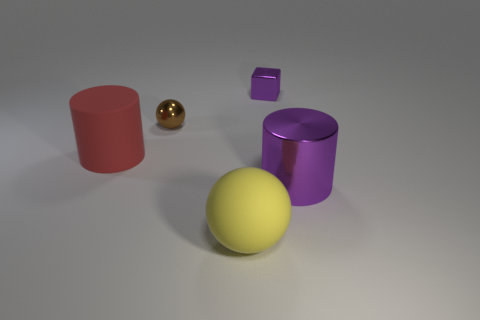Add 5 tiny red matte things. How many objects exist? 10 Subtract all purple cylinders. How many cylinders are left? 1 Subtract all cubes. How many objects are left? 4 Subtract all brown cylinders. How many gray blocks are left? 0 Subtract all yellow rubber spheres. Subtract all purple objects. How many objects are left? 2 Add 2 purple cylinders. How many purple cylinders are left? 3 Add 2 big gray objects. How many big gray objects exist? 2 Subtract 0 green balls. How many objects are left? 5 Subtract 1 spheres. How many spheres are left? 1 Subtract all yellow cylinders. Subtract all brown balls. How many cylinders are left? 2 